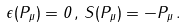Convert formula to latex. <formula><loc_0><loc_0><loc_500><loc_500>\epsilon ( P _ { \mu } ) = 0 \, , \, S ( P _ { \mu } ) = - P _ { \mu } \, .</formula> 